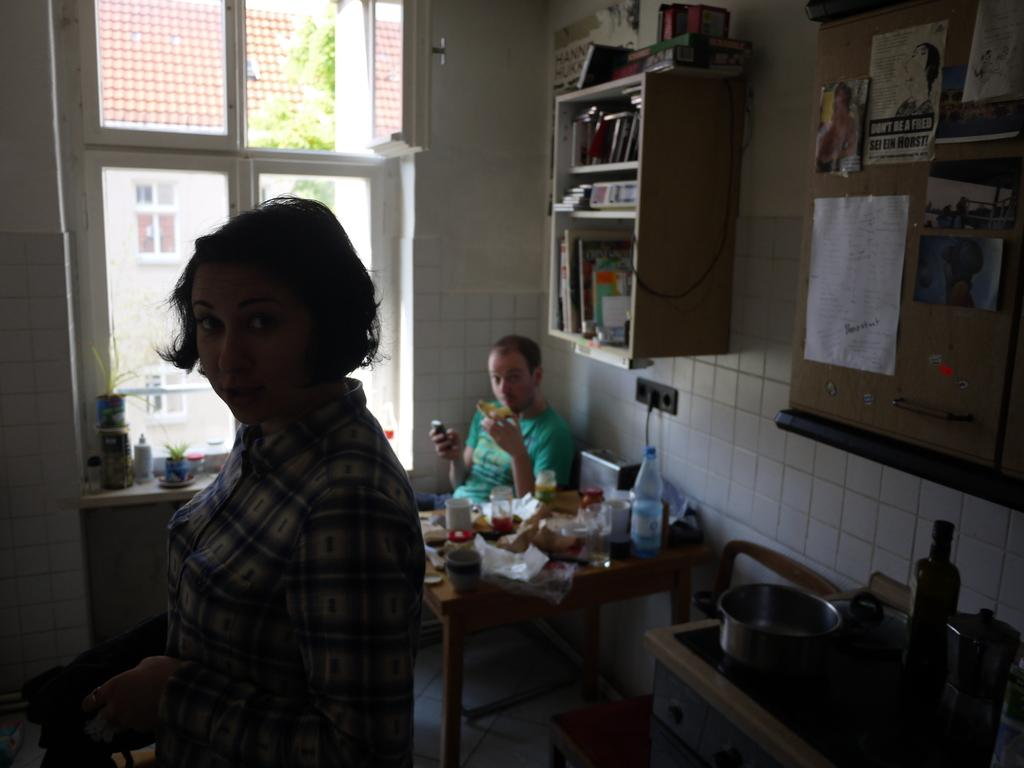What is the woman doing in the image? The woman is standing in the image. What is the man doing in the image? The man is seated on a chair in the image. What can be found on the table in the image? There are vessels, bottles, food, and a bookshelf on the wall in the image. How does the woman twist the bottles on the table in the image? There is no indication in the image that the woman is twisting any bottles; she is simply standing. 